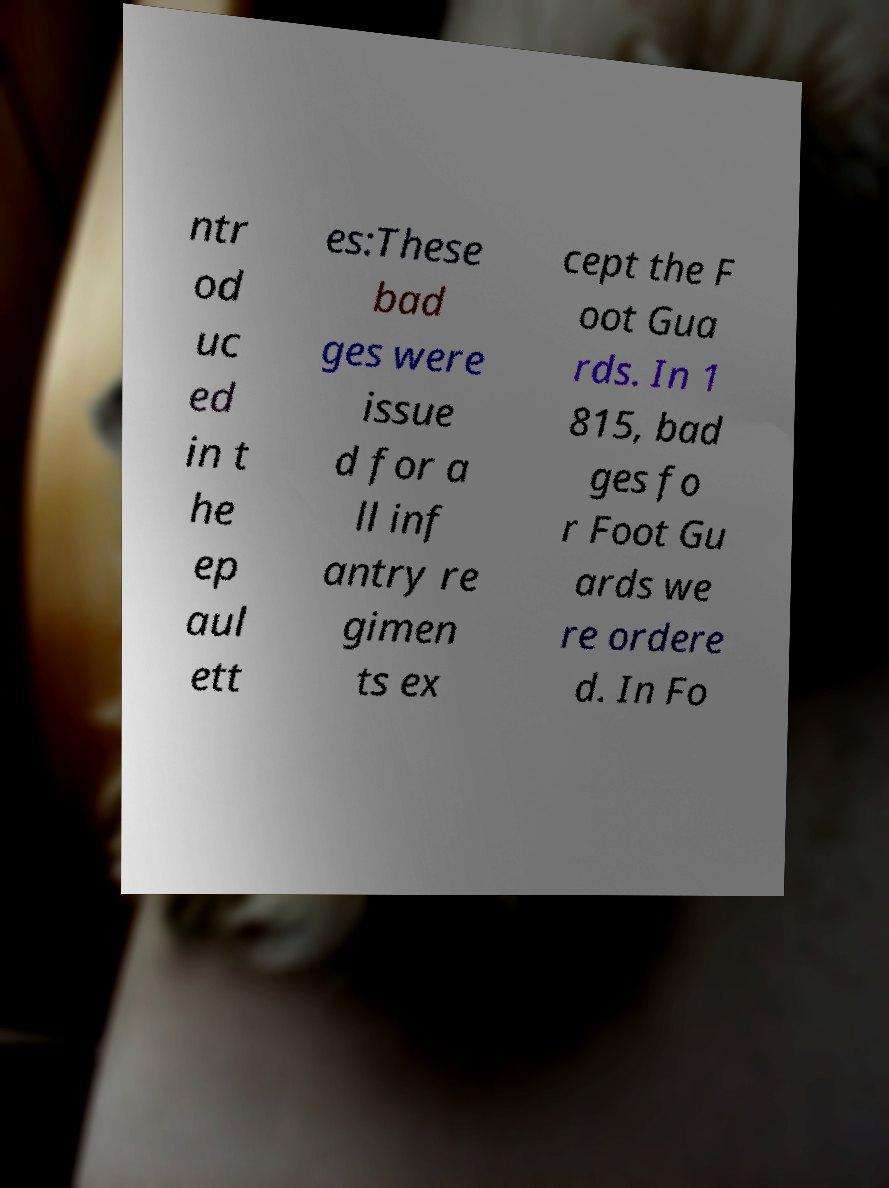Can you read and provide the text displayed in the image?This photo seems to have some interesting text. Can you extract and type it out for me? ntr od uc ed in t he ep aul ett es:These bad ges were issue d for a ll inf antry re gimen ts ex cept the F oot Gua rds. In 1 815, bad ges fo r Foot Gu ards we re ordere d. In Fo 